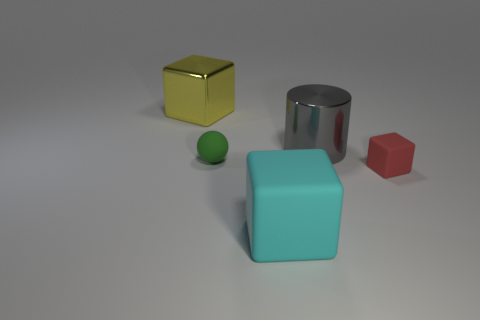Add 1 small blocks. How many objects exist? 6 Subtract all cubes. How many objects are left? 2 Subtract all big red metallic cubes. Subtract all small blocks. How many objects are left? 4 Add 5 shiny things. How many shiny things are left? 7 Add 2 yellow objects. How many yellow objects exist? 3 Subtract 0 cyan spheres. How many objects are left? 5 